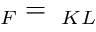Convert formula to latex. <formula><loc_0><loc_0><loc_500><loc_500>{ \Lambda } _ { F } = { \Lambda } _ { K L }</formula> 